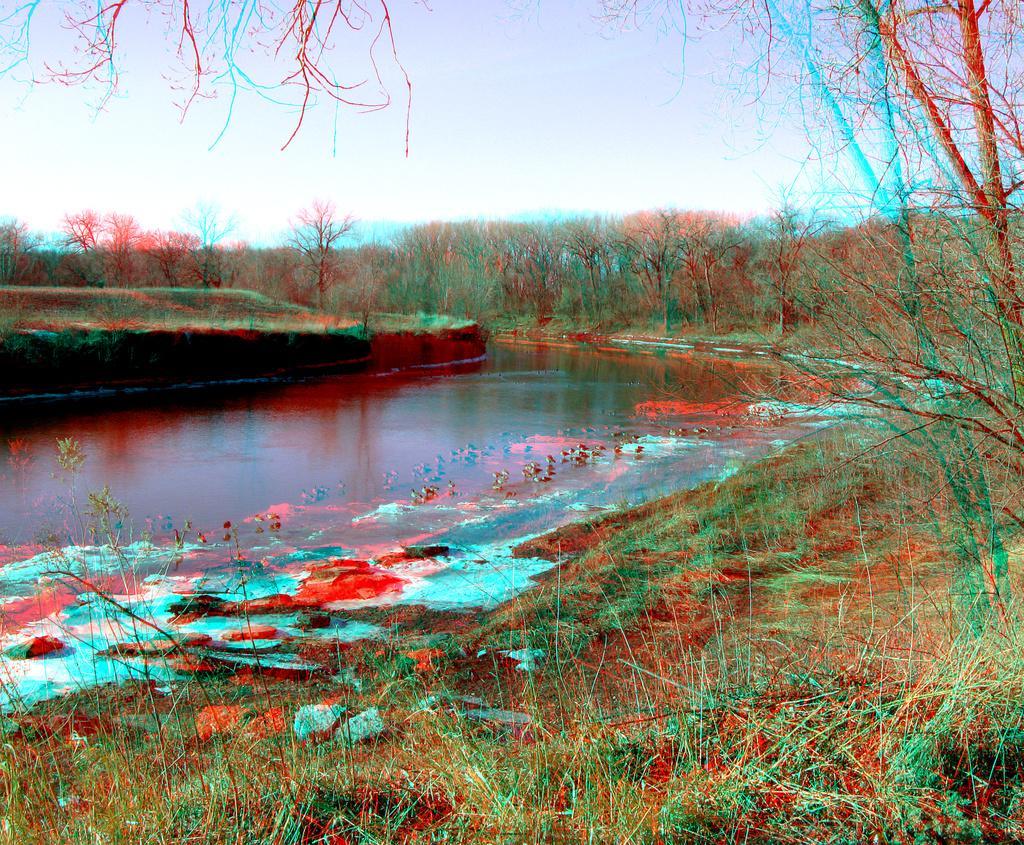Please provide a concise description of this image. In this image, we can see a lake and in the background, there are trees. 